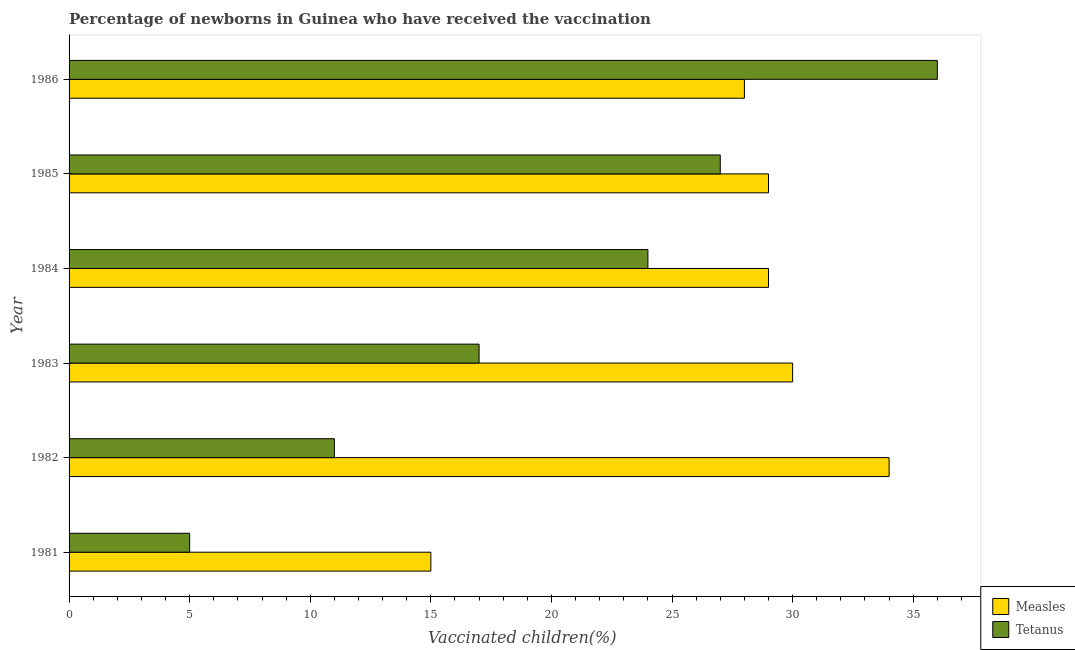How many different coloured bars are there?
Provide a short and direct response. 2. How many groups of bars are there?
Your answer should be very brief. 6. How many bars are there on the 6th tick from the top?
Provide a succinct answer. 2. How many bars are there on the 5th tick from the bottom?
Your answer should be very brief. 2. What is the label of the 5th group of bars from the top?
Make the answer very short. 1982. What is the percentage of newborns who received vaccination for tetanus in 1984?
Make the answer very short. 24. Across all years, what is the maximum percentage of newborns who received vaccination for tetanus?
Provide a succinct answer. 36. Across all years, what is the minimum percentage of newborns who received vaccination for measles?
Keep it short and to the point. 15. In which year was the percentage of newborns who received vaccination for tetanus minimum?
Make the answer very short. 1981. What is the total percentage of newborns who received vaccination for measles in the graph?
Ensure brevity in your answer.  165. What is the difference between the percentage of newborns who received vaccination for tetanus in 1981 and that in 1983?
Your response must be concise. -12. What is the difference between the percentage of newborns who received vaccination for measles in 1986 and the percentage of newborns who received vaccination for tetanus in 1984?
Offer a very short reply. 4. What is the average percentage of newborns who received vaccination for measles per year?
Ensure brevity in your answer.  27.5. In the year 1983, what is the difference between the percentage of newborns who received vaccination for measles and percentage of newborns who received vaccination for tetanus?
Make the answer very short. 13. What is the ratio of the percentage of newborns who received vaccination for tetanus in 1983 to that in 1985?
Keep it short and to the point. 0.63. Is the percentage of newborns who received vaccination for measles in 1981 less than that in 1983?
Provide a short and direct response. Yes. What is the difference between the highest and the lowest percentage of newborns who received vaccination for measles?
Your answer should be very brief. 19. In how many years, is the percentage of newborns who received vaccination for measles greater than the average percentage of newborns who received vaccination for measles taken over all years?
Your answer should be compact. 5. What does the 1st bar from the top in 1984 represents?
Your answer should be compact. Tetanus. What does the 1st bar from the bottom in 1986 represents?
Ensure brevity in your answer.  Measles. Are all the bars in the graph horizontal?
Offer a very short reply. Yes. What is the difference between two consecutive major ticks on the X-axis?
Give a very brief answer. 5. Are the values on the major ticks of X-axis written in scientific E-notation?
Keep it short and to the point. No. Does the graph contain any zero values?
Keep it short and to the point. No. Where does the legend appear in the graph?
Your answer should be very brief. Bottom right. How many legend labels are there?
Your answer should be very brief. 2. What is the title of the graph?
Your answer should be very brief. Percentage of newborns in Guinea who have received the vaccination. Does "Savings" appear as one of the legend labels in the graph?
Your response must be concise. No. What is the label or title of the X-axis?
Keep it short and to the point. Vaccinated children(%)
. What is the Vaccinated children(%)
 in Measles in 1981?
Your answer should be compact. 15. What is the Vaccinated children(%)
 in Tetanus in 1982?
Make the answer very short. 11. What is the Vaccinated children(%)
 of Measles in 1984?
Your response must be concise. 29. What is the Vaccinated children(%)
 in Tetanus in 1984?
Keep it short and to the point. 24. Across all years, what is the minimum Vaccinated children(%)
 in Measles?
Your answer should be compact. 15. Across all years, what is the minimum Vaccinated children(%)
 of Tetanus?
Your answer should be very brief. 5. What is the total Vaccinated children(%)
 in Measles in the graph?
Your answer should be very brief. 165. What is the total Vaccinated children(%)
 in Tetanus in the graph?
Give a very brief answer. 120. What is the difference between the Vaccinated children(%)
 of Measles in 1981 and that in 1982?
Ensure brevity in your answer.  -19. What is the difference between the Vaccinated children(%)
 of Tetanus in 1981 and that in 1982?
Provide a short and direct response. -6. What is the difference between the Vaccinated children(%)
 of Measles in 1981 and that in 1983?
Your response must be concise. -15. What is the difference between the Vaccinated children(%)
 in Tetanus in 1981 and that in 1984?
Your answer should be compact. -19. What is the difference between the Vaccinated children(%)
 of Measles in 1981 and that in 1985?
Offer a terse response. -14. What is the difference between the Vaccinated children(%)
 of Tetanus in 1981 and that in 1986?
Ensure brevity in your answer.  -31. What is the difference between the Vaccinated children(%)
 of Tetanus in 1982 and that in 1983?
Give a very brief answer. -6. What is the difference between the Vaccinated children(%)
 in Measles in 1982 and that in 1984?
Your response must be concise. 5. What is the difference between the Vaccinated children(%)
 of Tetanus in 1982 and that in 1984?
Your answer should be compact. -13. What is the difference between the Vaccinated children(%)
 of Measles in 1982 and that in 1986?
Offer a terse response. 6. What is the difference between the Vaccinated children(%)
 of Tetanus in 1982 and that in 1986?
Offer a terse response. -25. What is the difference between the Vaccinated children(%)
 in Measles in 1983 and that in 1984?
Provide a succinct answer. 1. What is the difference between the Vaccinated children(%)
 in Tetanus in 1983 and that in 1984?
Your answer should be very brief. -7. What is the difference between the Vaccinated children(%)
 of Measles in 1983 and that in 1985?
Provide a succinct answer. 1. What is the difference between the Vaccinated children(%)
 of Tetanus in 1983 and that in 1985?
Your answer should be compact. -10. What is the difference between the Vaccinated children(%)
 in Tetanus in 1983 and that in 1986?
Your response must be concise. -19. What is the difference between the Vaccinated children(%)
 in Measles in 1984 and that in 1985?
Your answer should be compact. 0. What is the difference between the Vaccinated children(%)
 in Tetanus in 1984 and that in 1986?
Your answer should be very brief. -12. What is the difference between the Vaccinated children(%)
 in Measles in 1981 and the Vaccinated children(%)
 in Tetanus in 1984?
Provide a short and direct response. -9. What is the difference between the Vaccinated children(%)
 in Measles in 1981 and the Vaccinated children(%)
 in Tetanus in 1985?
Provide a succinct answer. -12. What is the difference between the Vaccinated children(%)
 in Measles in 1981 and the Vaccinated children(%)
 in Tetanus in 1986?
Your answer should be very brief. -21. What is the difference between the Vaccinated children(%)
 of Measles in 1982 and the Vaccinated children(%)
 of Tetanus in 1983?
Make the answer very short. 17. What is the difference between the Vaccinated children(%)
 of Measles in 1982 and the Vaccinated children(%)
 of Tetanus in 1985?
Offer a terse response. 7. What is the difference between the Vaccinated children(%)
 in Measles in 1983 and the Vaccinated children(%)
 in Tetanus in 1986?
Give a very brief answer. -6. What is the difference between the Vaccinated children(%)
 in Measles in 1984 and the Vaccinated children(%)
 in Tetanus in 1986?
Offer a very short reply. -7. What is the average Vaccinated children(%)
 in Tetanus per year?
Provide a short and direct response. 20. In the year 1981, what is the difference between the Vaccinated children(%)
 of Measles and Vaccinated children(%)
 of Tetanus?
Make the answer very short. 10. In the year 1982, what is the difference between the Vaccinated children(%)
 in Measles and Vaccinated children(%)
 in Tetanus?
Your answer should be very brief. 23. What is the ratio of the Vaccinated children(%)
 of Measles in 1981 to that in 1982?
Ensure brevity in your answer.  0.44. What is the ratio of the Vaccinated children(%)
 of Tetanus in 1981 to that in 1982?
Provide a succinct answer. 0.45. What is the ratio of the Vaccinated children(%)
 in Measles in 1981 to that in 1983?
Your response must be concise. 0.5. What is the ratio of the Vaccinated children(%)
 in Tetanus in 1981 to that in 1983?
Keep it short and to the point. 0.29. What is the ratio of the Vaccinated children(%)
 in Measles in 1981 to that in 1984?
Your response must be concise. 0.52. What is the ratio of the Vaccinated children(%)
 in Tetanus in 1981 to that in 1984?
Provide a succinct answer. 0.21. What is the ratio of the Vaccinated children(%)
 in Measles in 1981 to that in 1985?
Provide a short and direct response. 0.52. What is the ratio of the Vaccinated children(%)
 in Tetanus in 1981 to that in 1985?
Ensure brevity in your answer.  0.19. What is the ratio of the Vaccinated children(%)
 of Measles in 1981 to that in 1986?
Your answer should be very brief. 0.54. What is the ratio of the Vaccinated children(%)
 of Tetanus in 1981 to that in 1986?
Offer a very short reply. 0.14. What is the ratio of the Vaccinated children(%)
 in Measles in 1982 to that in 1983?
Your answer should be compact. 1.13. What is the ratio of the Vaccinated children(%)
 in Tetanus in 1982 to that in 1983?
Make the answer very short. 0.65. What is the ratio of the Vaccinated children(%)
 in Measles in 1982 to that in 1984?
Provide a succinct answer. 1.17. What is the ratio of the Vaccinated children(%)
 in Tetanus in 1982 to that in 1984?
Make the answer very short. 0.46. What is the ratio of the Vaccinated children(%)
 of Measles in 1982 to that in 1985?
Give a very brief answer. 1.17. What is the ratio of the Vaccinated children(%)
 of Tetanus in 1982 to that in 1985?
Make the answer very short. 0.41. What is the ratio of the Vaccinated children(%)
 in Measles in 1982 to that in 1986?
Make the answer very short. 1.21. What is the ratio of the Vaccinated children(%)
 in Tetanus in 1982 to that in 1986?
Provide a succinct answer. 0.31. What is the ratio of the Vaccinated children(%)
 of Measles in 1983 to that in 1984?
Provide a short and direct response. 1.03. What is the ratio of the Vaccinated children(%)
 of Tetanus in 1983 to that in 1984?
Provide a succinct answer. 0.71. What is the ratio of the Vaccinated children(%)
 of Measles in 1983 to that in 1985?
Give a very brief answer. 1.03. What is the ratio of the Vaccinated children(%)
 of Tetanus in 1983 to that in 1985?
Keep it short and to the point. 0.63. What is the ratio of the Vaccinated children(%)
 in Measles in 1983 to that in 1986?
Your answer should be compact. 1.07. What is the ratio of the Vaccinated children(%)
 of Tetanus in 1983 to that in 1986?
Offer a very short reply. 0.47. What is the ratio of the Vaccinated children(%)
 of Measles in 1984 to that in 1985?
Provide a short and direct response. 1. What is the ratio of the Vaccinated children(%)
 of Measles in 1984 to that in 1986?
Your answer should be compact. 1.04. What is the ratio of the Vaccinated children(%)
 in Measles in 1985 to that in 1986?
Keep it short and to the point. 1.04. What is the ratio of the Vaccinated children(%)
 of Tetanus in 1985 to that in 1986?
Make the answer very short. 0.75. 